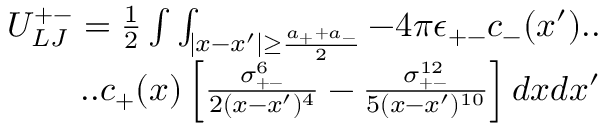<formula> <loc_0><loc_0><loc_500><loc_500>\begin{array} { r } { U _ { L J } ^ { + - } = \frac { 1 } { 2 } \int \int _ { | x - x ^ { \prime } | \geq \frac { a _ { + } + a _ { - } } { 2 } } - 4 \pi \epsilon _ { + - } c _ { - } ( x ^ { \prime } ) . . } \\ { . . c _ { + } ( x ) \left [ \frac { \sigma _ { + - } ^ { 6 } } { 2 ( x - x ^ { \prime } ) ^ { 4 } } - \frac { \sigma _ { + - } ^ { 1 2 } } { 5 ( x - x ^ { \prime } ) ^ { 1 0 } } \right ] d x d x ^ { \prime } } \end{array}</formula> 